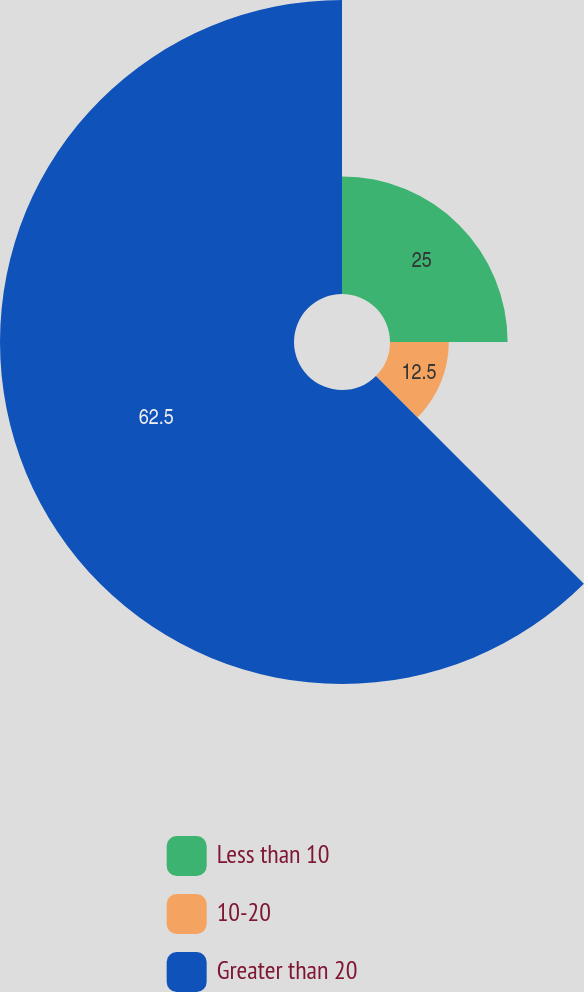Convert chart to OTSL. <chart><loc_0><loc_0><loc_500><loc_500><pie_chart><fcel>Less than 10<fcel>10-20<fcel>Greater than 20<nl><fcel>25.0%<fcel>12.5%<fcel>62.5%<nl></chart> 